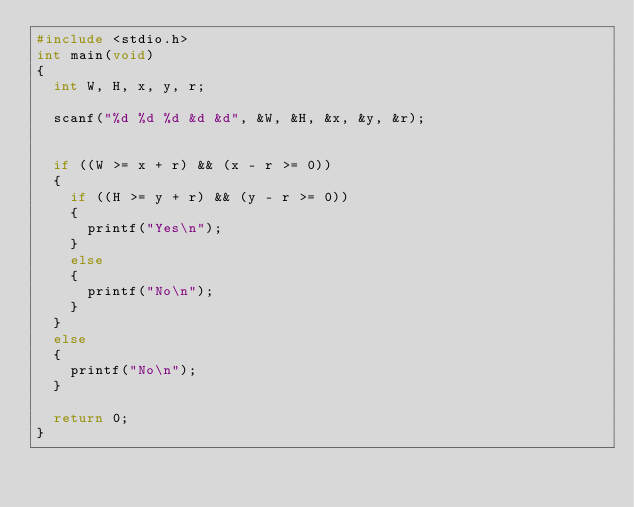<code> <loc_0><loc_0><loc_500><loc_500><_C_>#include <stdio.h>
int main(void)
{
	int W, H, x, y, r;

	scanf("%d %d %d &d &d", &W, &H, &x, &y, &r);


	if ((W >= x + r) && (x - r >= 0))
	{
		if ((H >= y + r) && (y - r >= 0))
		{
			printf("Yes\n");
		}
		else
		{
			printf("No\n");
		}
	}
	else
	{
		printf("No\n");
	}

	return 0;
}
</code> 